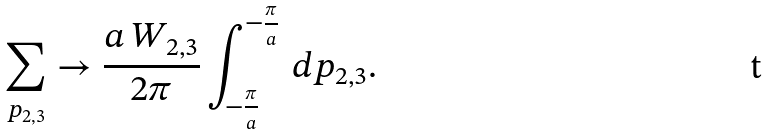Convert formula to latex. <formula><loc_0><loc_0><loc_500><loc_500>\sum _ { p _ { 2 , 3 } } \rightarrow \frac { a \, W _ { 2 , 3 } } { 2 \pi } \int _ { - \frac { \pi } { a } } ^ { - \frac { \pi } { a } } \, d p _ { 2 , 3 } .</formula> 